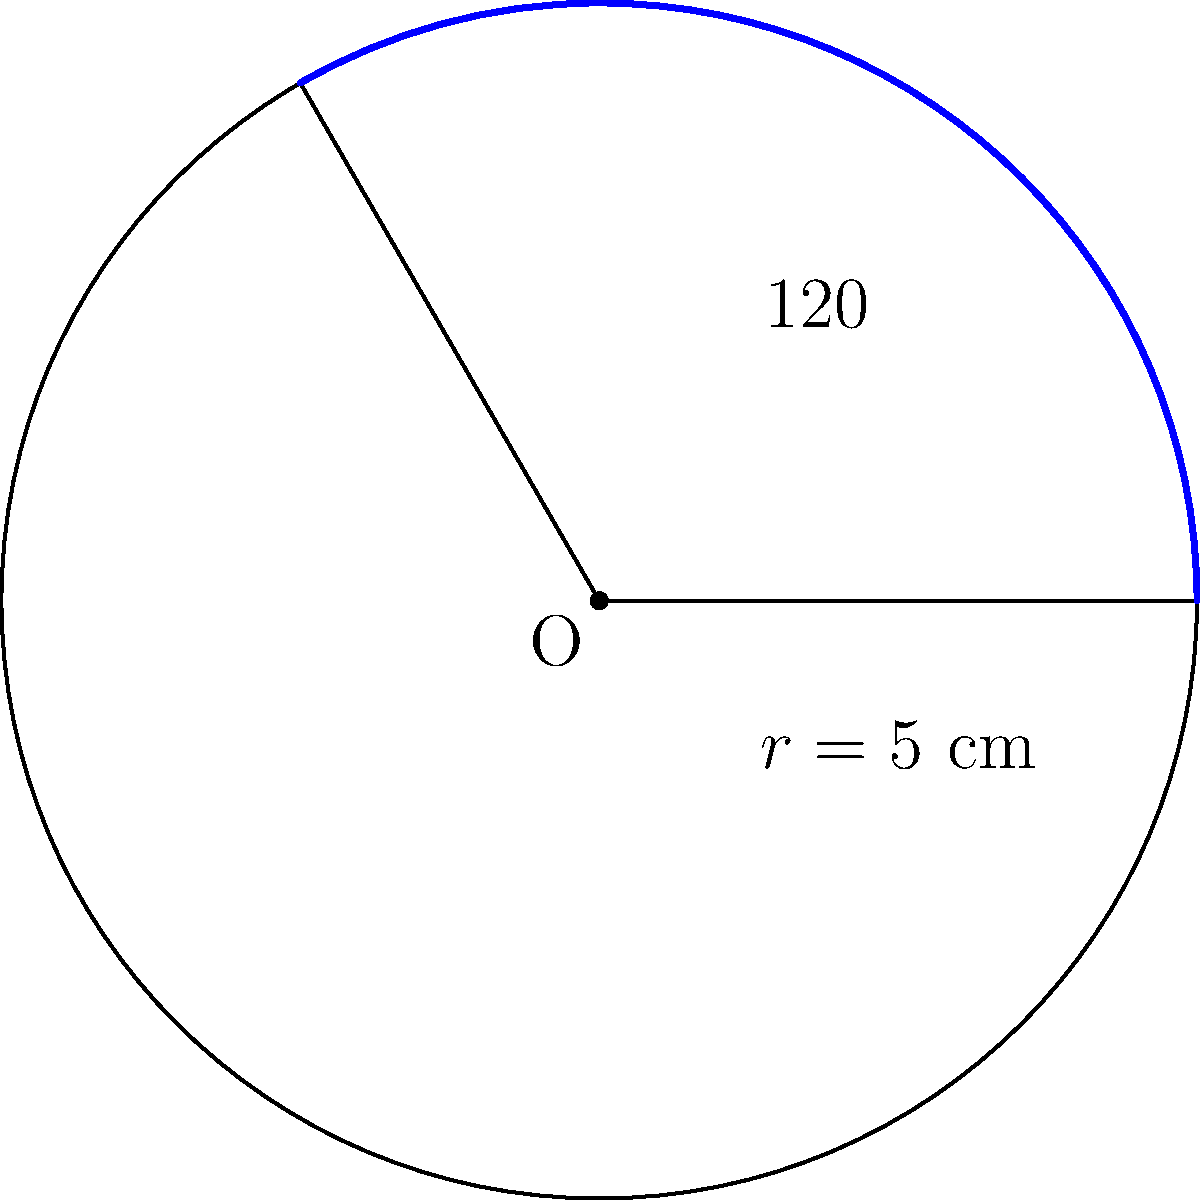In the circular sector shown above, the central angle is $120°$ and the radius is $5$ cm. Calculate the area of the sector, rounding your answer to the nearest square centimeter. As a Canadian writer who didn't get the award, how might this calculation relate to the portion of recognition you received compared to the winner? Let's approach this step-by-step:

1) The formula for the area of a circular sector is:

   $$A = \frac{\theta}{360°} \cdot \pi r^2$$

   Where $\theta$ is the central angle in degrees, and $r$ is the radius.

2) We're given:
   $\theta = 120°$
   $r = 5$ cm

3) Let's substitute these values into our formula:

   $$A = \frac{120°}{360°} \cdot \pi \cdot 5^2$$

4) Simplify:
   $$A = \frac{1}{3} \cdot \pi \cdot 25$$

5) Calculate:
   $$A = \frac{25\pi}{3} \approx 26.18 \text{ cm}^2$$

6) Rounding to the nearest square centimeter:
   $$A \approx 26 \text{ cm}^2$$

As a Canadian writer who didn't get the award, this calculation might symbolize the recognition you received compared to the winner. The sector represents your portion of attention or acclaim, while the full circle could represent the total recognition available. Just as the sector is a significant part of the circle (one-third), your work and talent are still a valuable part of the literary landscape, even if you didn't win this particular award.
Answer: 26 cm² 